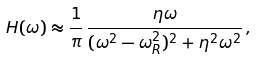Convert formula to latex. <formula><loc_0><loc_0><loc_500><loc_500>H ( \omega ) \approx \frac { 1 } { \pi } \, \frac { \eta \omega } { ( \omega ^ { 2 } - \omega _ { R } ^ { 2 } ) ^ { 2 } + \eta ^ { 2 } \omega ^ { 2 } } \, ,</formula> 